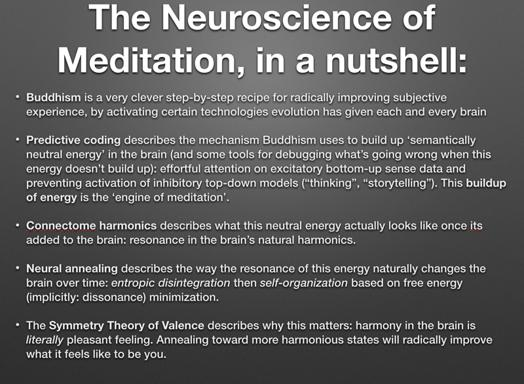How is the Symmetry Theory of Valence related to this text? The Symmetry Theory of Valence is central to the text's discussion of how subjective well-being and neural harmony are interconnected. It argues that achieving symmetric, harmonious neural states is not only desirable but essential for enhancing personal subjective experience, as such states directly contribute to feelings of pleasure and satisfaction. 